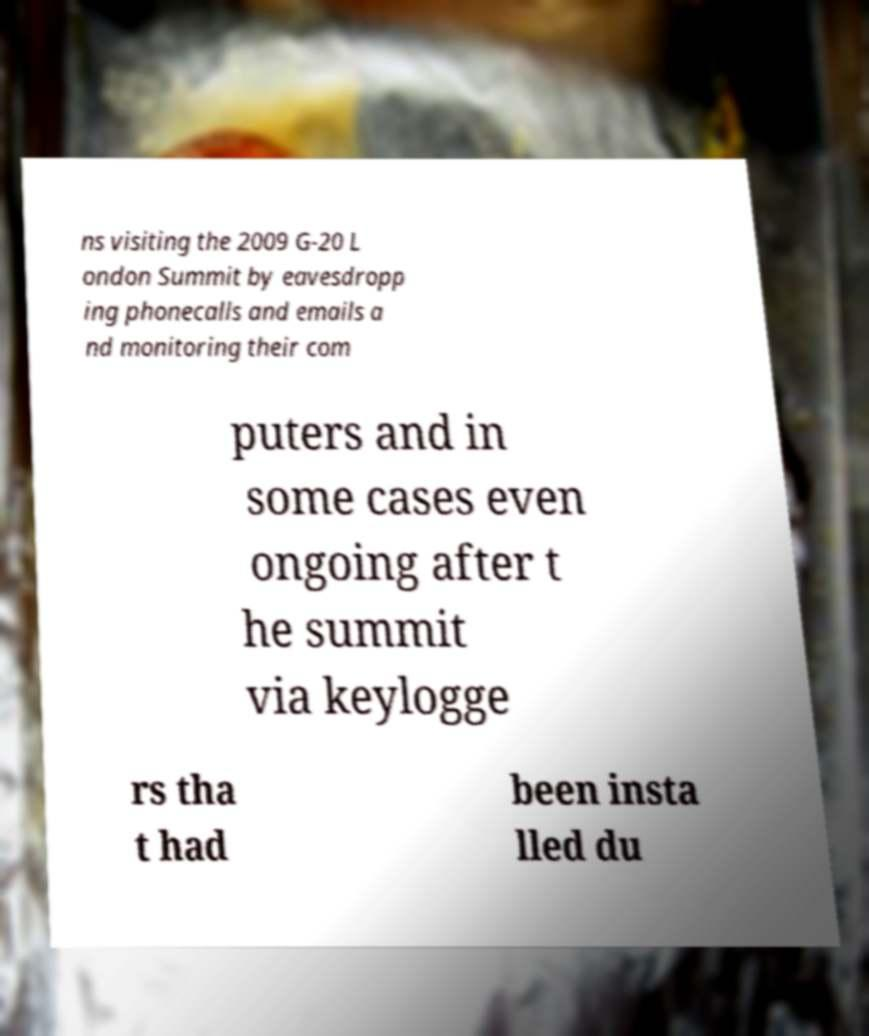Could you assist in decoding the text presented in this image and type it out clearly? ns visiting the 2009 G-20 L ondon Summit by eavesdropp ing phonecalls and emails a nd monitoring their com puters and in some cases even ongoing after t he summit via keylogge rs tha t had been insta lled du 